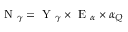<formula> <loc_0><loc_0><loc_500><loc_500>N _ { \gamma } = Y _ { \gamma } \times E _ { \alpha } \times \alpha _ { Q }</formula> 